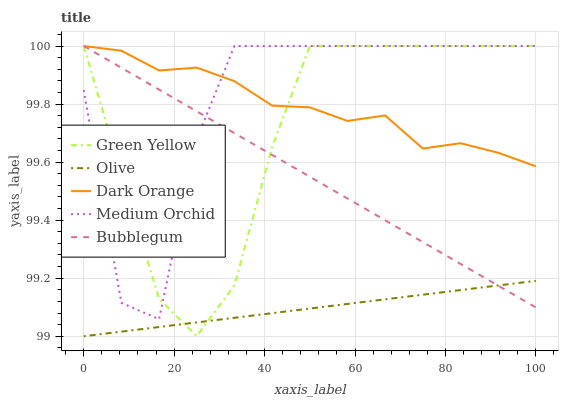Does Olive have the minimum area under the curve?
Answer yes or no. Yes. Does Medium Orchid have the maximum area under the curve?
Answer yes or no. Yes. Does Dark Orange have the minimum area under the curve?
Answer yes or no. No. Does Dark Orange have the maximum area under the curve?
Answer yes or no. No. Is Bubblegum the smoothest?
Answer yes or no. Yes. Is Medium Orchid the roughest?
Answer yes or no. Yes. Is Dark Orange the smoothest?
Answer yes or no. No. Is Dark Orange the roughest?
Answer yes or no. No. Does Medium Orchid have the lowest value?
Answer yes or no. No. Is Olive less than Medium Orchid?
Answer yes or no. Yes. Is Dark Orange greater than Olive?
Answer yes or no. Yes. Does Olive intersect Medium Orchid?
Answer yes or no. No. 